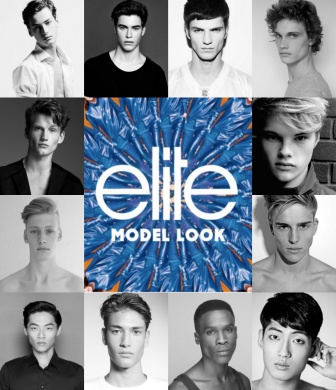What kind of emotions do the models' expressions evoke in you? The models' expressions, with their direct and intense gazes, evoke a sense of confidence and determination. Each model's unique look and poised demeanor contribute to an overall feeling of ambition and aspiration. The black and white palette enhances their serious, yet captivating presence, drawing the viewer to contemplate their stories and experiences. 